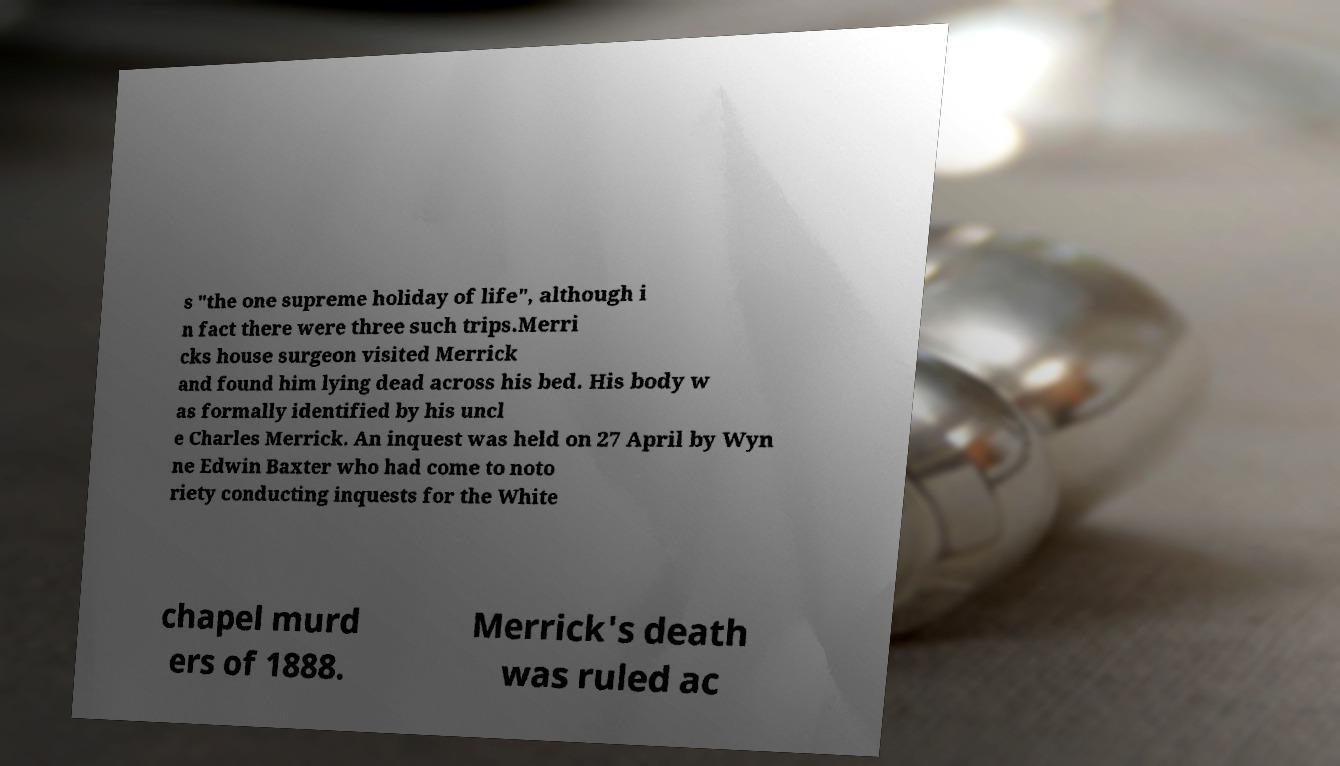There's text embedded in this image that I need extracted. Can you transcribe it verbatim? s "the one supreme holiday of life", although i n fact there were three such trips.Merri cks house surgeon visited Merrick and found him lying dead across his bed. His body w as formally identified by his uncl e Charles Merrick. An inquest was held on 27 April by Wyn ne Edwin Baxter who had come to noto riety conducting inquests for the White chapel murd ers of 1888. Merrick's death was ruled ac 